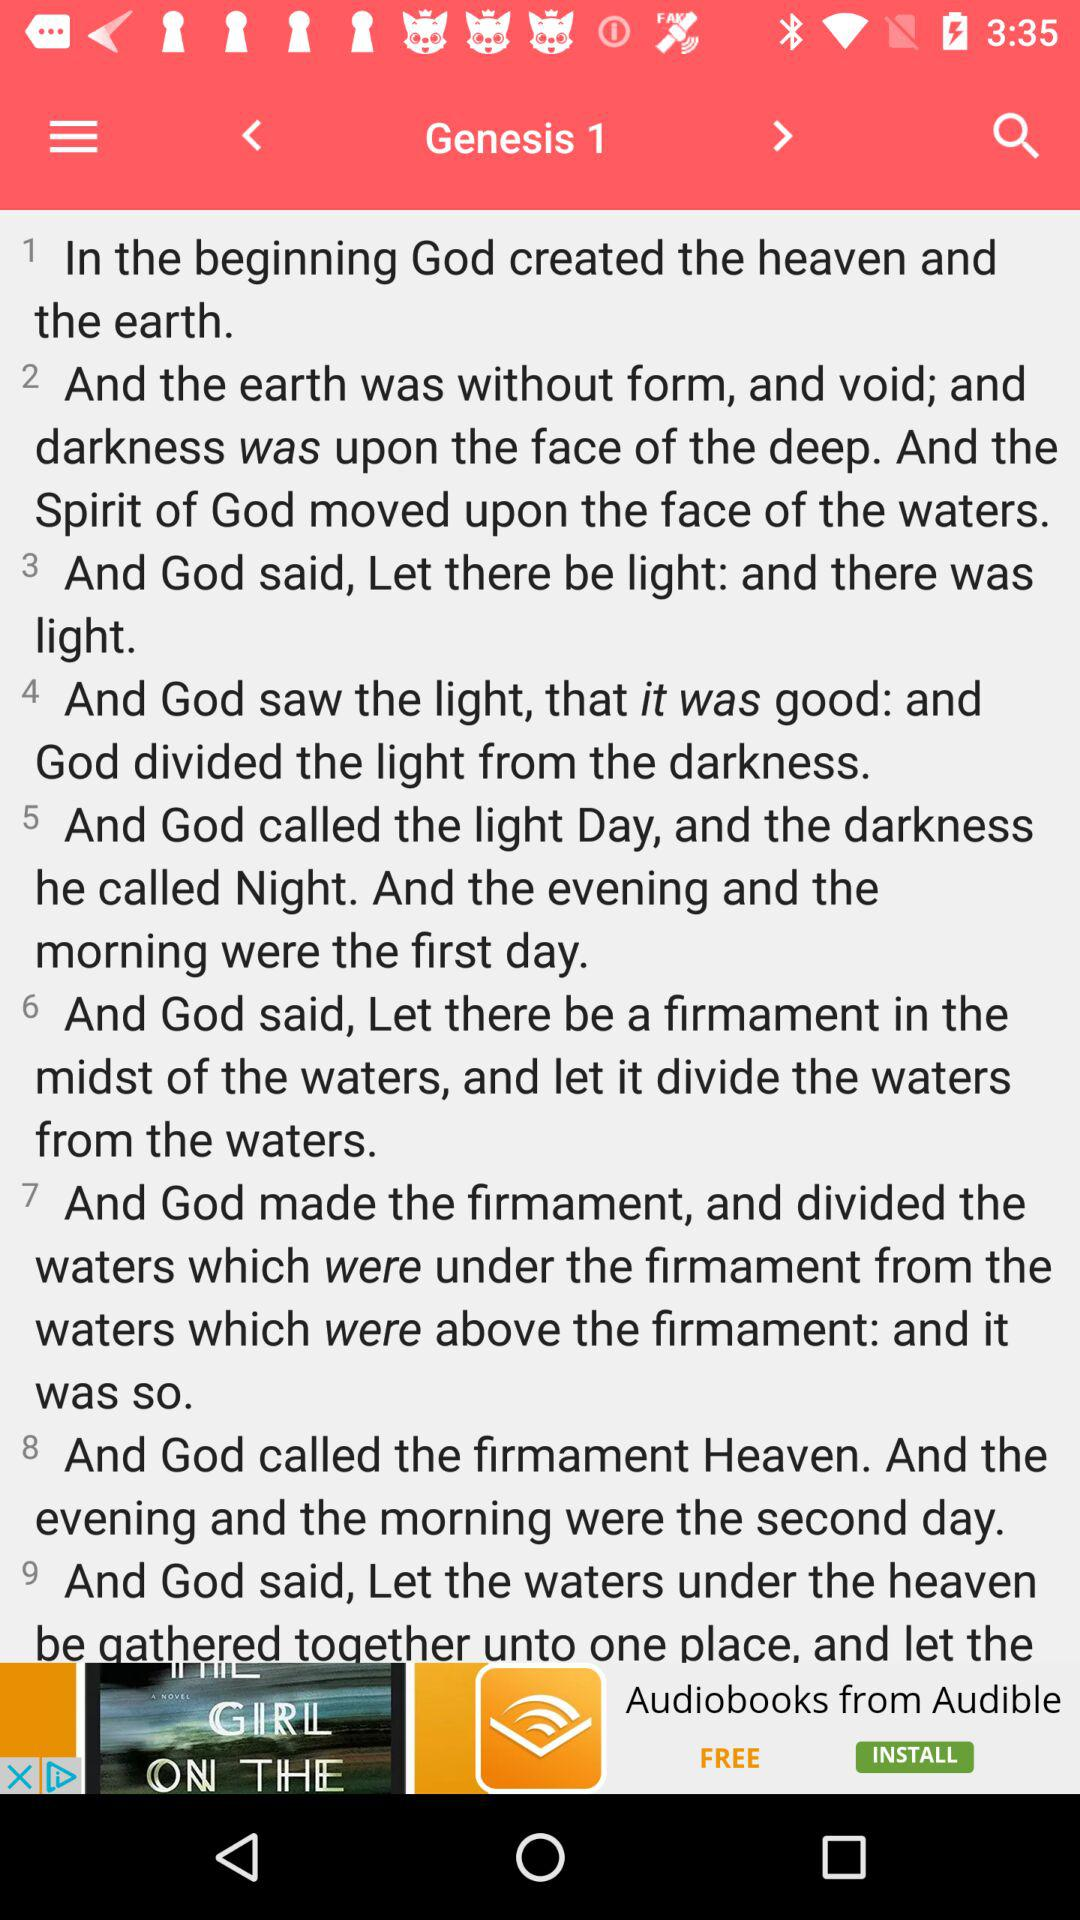Which chapter number of "Genesis" is displayed? The displayed chapter number is 1. 